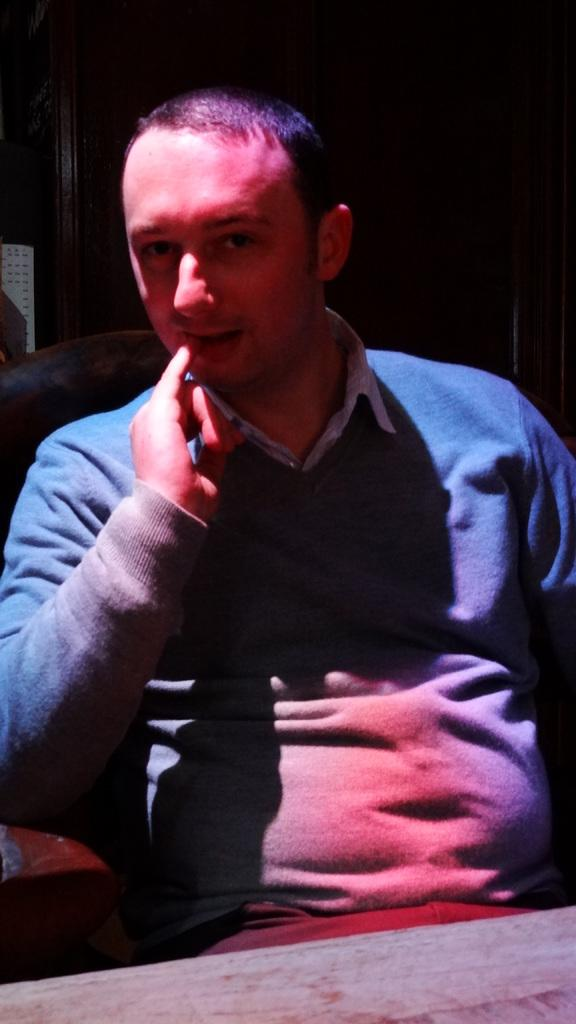Who or what is the main subject in the image? There is a person in the image. What is the person wearing? The person is wearing a sweater. What is the person's position in the image? The person is sitting on a chair. What object is in front of the person? There is a table in front of the person. What type of spoon is the person using to control the station's behavior in the image? There is no spoon or station present in the image; it only features a person sitting on a chair with a table in front of them. 